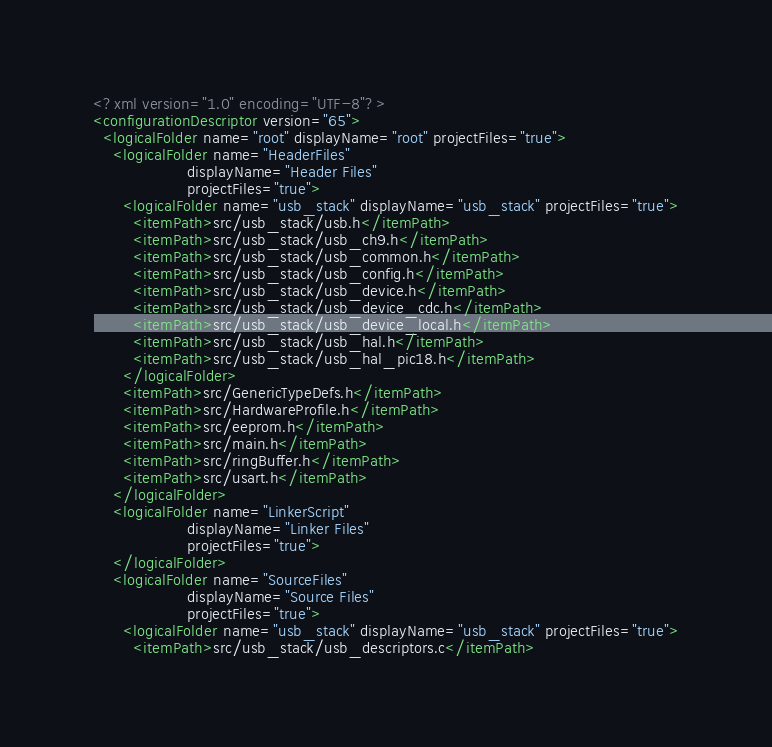<code> <loc_0><loc_0><loc_500><loc_500><_XML_><?xml version="1.0" encoding="UTF-8"?>
<configurationDescriptor version="65">
  <logicalFolder name="root" displayName="root" projectFiles="true">
    <logicalFolder name="HeaderFiles"
                   displayName="Header Files"
                   projectFiles="true">
      <logicalFolder name="usb_stack" displayName="usb_stack" projectFiles="true">
        <itemPath>src/usb_stack/usb.h</itemPath>
        <itemPath>src/usb_stack/usb_ch9.h</itemPath>
        <itemPath>src/usb_stack/usb_common.h</itemPath>
        <itemPath>src/usb_stack/usb_config.h</itemPath>
        <itemPath>src/usb_stack/usb_device.h</itemPath>
        <itemPath>src/usb_stack/usb_device_cdc.h</itemPath>
        <itemPath>src/usb_stack/usb_device_local.h</itemPath>
        <itemPath>src/usb_stack/usb_hal.h</itemPath>
        <itemPath>src/usb_stack/usb_hal_pic18.h</itemPath>
      </logicalFolder>
      <itemPath>src/GenericTypeDefs.h</itemPath>
      <itemPath>src/HardwareProfile.h</itemPath>
      <itemPath>src/eeprom.h</itemPath>
      <itemPath>src/main.h</itemPath>
      <itemPath>src/ringBuffer.h</itemPath>
      <itemPath>src/usart.h</itemPath>
    </logicalFolder>
    <logicalFolder name="LinkerScript"
                   displayName="Linker Files"
                   projectFiles="true">
    </logicalFolder>
    <logicalFolder name="SourceFiles"
                   displayName="Source Files"
                   projectFiles="true">
      <logicalFolder name="usb_stack" displayName="usb_stack" projectFiles="true">
        <itemPath>src/usb_stack/usb_descriptors.c</itemPath></code> 